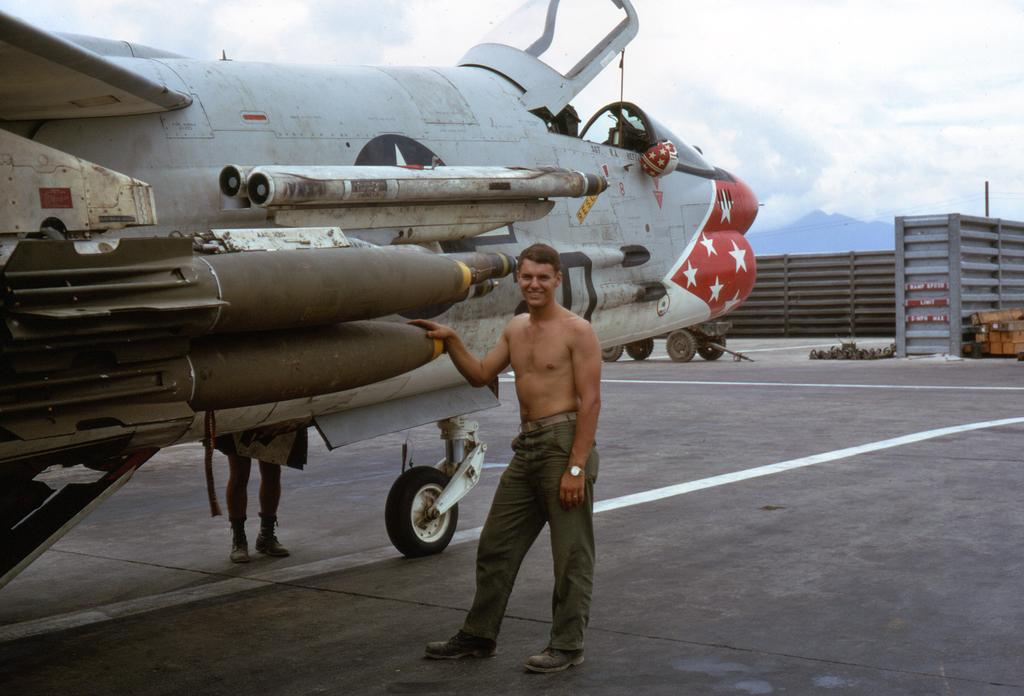What is the main subject of the picture? The main subject of the picture is a jet plane. Are the jet planes in any specific position? Some of the jet planes are standing. What other type of vehicle can be seen in the picture? There is a vehicle in the picture. How would you describe the sky in the image? The sky is blue and cloudy. Can you tell me how many friends are sitting next to the jet plane in the image? There are no friends present in the image; it features jet planes and a vehicle. What type of beast can be seen interacting with the jet plane in the image? There is no beast present in the image; only the jet planes, vehicle, and sky are visible. 